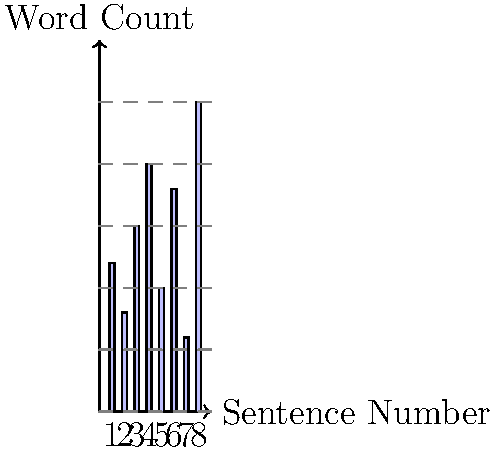Analyze the bar graph representing sentence lengths in a text passage. Which sentence exhibits the greatest contrast in length compared to its immediate neighbors, and by how many words does it differ from the average of these adjacent sentences? To solve this problem, we need to follow these steps:

1. Identify the length of each sentence from the bar graph:
   Sentence 1: 12 words
   Sentence 2: 8 words
   Sentence 3: 15 words
   Sentence 4: 20 words
   Sentence 5: 10 words
   Sentence 6: 18 words
   Sentence 7: 6 words
   Sentence 8: 25 words

2. Calculate the difference between each sentence and its neighbors:
   Sentence 1: |12 - 8| = 4 (only one neighbor)
   Sentence 2: |8 - 12| + |8 - 15| = 4 + 7 = 11
   Sentence 3: |15 - 8| + |15 - 20| = 7 + 5 = 12
   Sentence 4: |20 - 15| + |20 - 10| = 5 + 10 = 15
   Sentence 5: |10 - 20| + |10 - 18| = 10 + 8 = 18
   Sentence 6: |18 - 10| + |18 - 6| = 8 + 12 = 20
   Sentence 7: |6 - 18| + |6 - 25| = 12 + 19 = 31
   Sentence 8: |25 - 6| = 19 (only one neighbor)

3. Identify the sentence with the greatest total difference: Sentence 7 (31 words)

4. Calculate the average length of its neighbors:
   (Sentence 6 + Sentence 8) / 2 = (18 + 25) / 2 = 21.5 words

5. Calculate the difference between Sentence 7 and the average of its neighbors:
   |6 - 21.5| = 15.5 words

Therefore, Sentence 7 exhibits the greatest contrast in length compared to its immediate neighbors, differing by 15.5 words from the average of its adjacent sentences.
Answer: Sentence 7, 15.5 words 